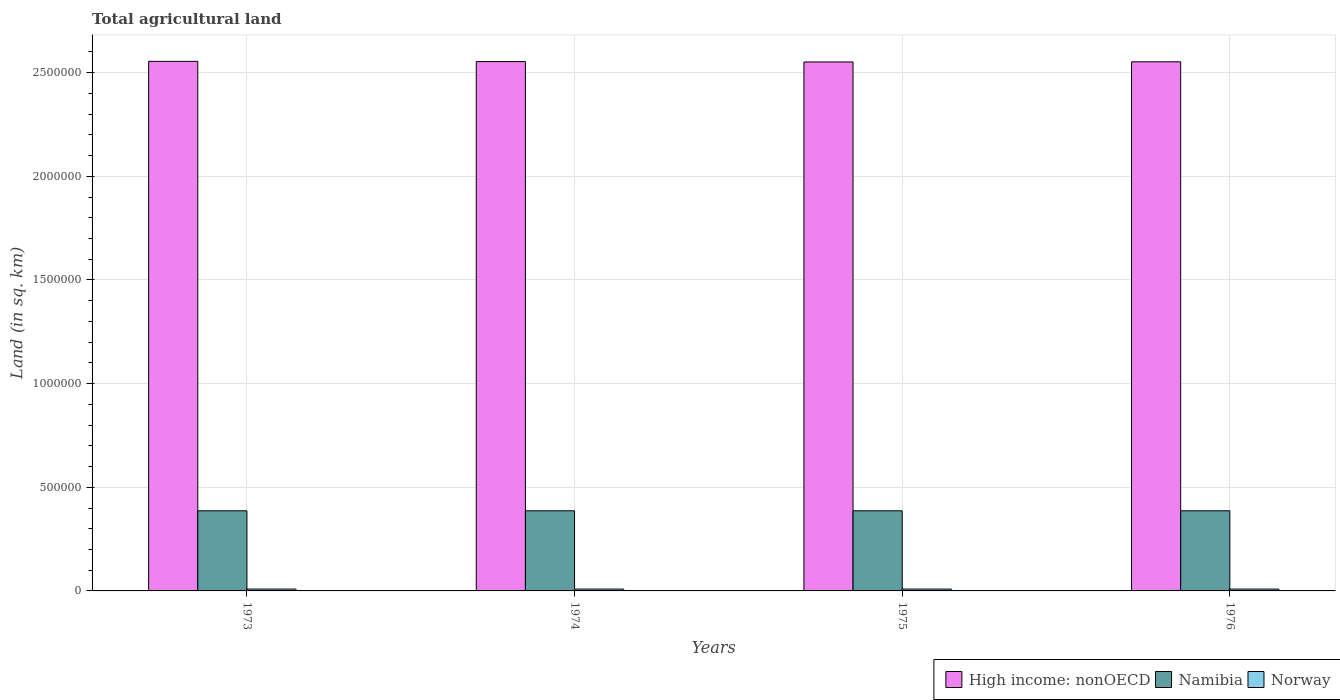Are the number of bars on each tick of the X-axis equal?
Provide a short and direct response. Yes. How many bars are there on the 2nd tick from the left?
Your answer should be compact. 3. What is the label of the 2nd group of bars from the left?
Your answer should be compact. 1974. In how many cases, is the number of bars for a given year not equal to the number of legend labels?
Your answer should be compact. 0. What is the total agricultural land in Namibia in 1974?
Give a very brief answer. 3.87e+05. Across all years, what is the maximum total agricultural land in High income: nonOECD?
Provide a succinct answer. 2.55e+06. Across all years, what is the minimum total agricultural land in High income: nonOECD?
Offer a very short reply. 2.55e+06. In which year was the total agricultural land in High income: nonOECD maximum?
Offer a very short reply. 1973. In which year was the total agricultural land in High income: nonOECD minimum?
Offer a very short reply. 1975. What is the total total agricultural land in High income: nonOECD in the graph?
Provide a short and direct response. 1.02e+07. What is the difference between the total agricultural land in Namibia in 1974 and that in 1976?
Keep it short and to the point. -20. What is the difference between the total agricultural land in Norway in 1976 and the total agricultural land in Namibia in 1974?
Provide a succinct answer. -3.78e+05. What is the average total agricultural land in Norway per year?
Ensure brevity in your answer.  8997.5. In the year 1975, what is the difference between the total agricultural land in Norway and total agricultural land in Namibia?
Your answer should be very brief. -3.78e+05. What is the ratio of the total agricultural land in High income: nonOECD in 1973 to that in 1975?
Provide a short and direct response. 1. Is the total agricultural land in Norway in 1974 less than that in 1976?
Provide a short and direct response. No. What is the difference between the highest and the lowest total agricultural land in Namibia?
Give a very brief answer. 20. In how many years, is the total agricultural land in High income: nonOECD greater than the average total agricultural land in High income: nonOECD taken over all years?
Make the answer very short. 2. What does the 2nd bar from the left in 1975 represents?
Ensure brevity in your answer.  Namibia. What does the 3rd bar from the right in 1976 represents?
Your answer should be compact. High income: nonOECD. Is it the case that in every year, the sum of the total agricultural land in Norway and total agricultural land in Namibia is greater than the total agricultural land in High income: nonOECD?
Your answer should be very brief. No. Are all the bars in the graph horizontal?
Provide a short and direct response. No. What is the difference between two consecutive major ticks on the Y-axis?
Offer a very short reply. 5.00e+05. Are the values on the major ticks of Y-axis written in scientific E-notation?
Your answer should be very brief. No. Does the graph contain grids?
Offer a very short reply. Yes. How are the legend labels stacked?
Keep it short and to the point. Horizontal. What is the title of the graph?
Your answer should be compact. Total agricultural land. Does "Vanuatu" appear as one of the legend labels in the graph?
Give a very brief answer. No. What is the label or title of the Y-axis?
Give a very brief answer. Land (in sq. km). What is the Land (in sq. km) in High income: nonOECD in 1973?
Offer a terse response. 2.55e+06. What is the Land (in sq. km) of Namibia in 1973?
Your answer should be compact. 3.87e+05. What is the Land (in sq. km) of Norway in 1973?
Your response must be concise. 9040. What is the Land (in sq. km) of High income: nonOECD in 1974?
Your answer should be compact. 2.55e+06. What is the Land (in sq. km) of Namibia in 1974?
Provide a succinct answer. 3.87e+05. What is the Land (in sq. km) of Norway in 1974?
Your answer should be compact. 9010. What is the Land (in sq. km) of High income: nonOECD in 1975?
Offer a terse response. 2.55e+06. What is the Land (in sq. km) of Namibia in 1975?
Your response must be concise. 3.87e+05. What is the Land (in sq. km) in Norway in 1975?
Keep it short and to the point. 8980. What is the Land (in sq. km) of High income: nonOECD in 1976?
Provide a succinct answer. 2.55e+06. What is the Land (in sq. km) in Namibia in 1976?
Ensure brevity in your answer.  3.87e+05. What is the Land (in sq. km) of Norway in 1976?
Ensure brevity in your answer.  8960. Across all years, what is the maximum Land (in sq. km) in High income: nonOECD?
Offer a terse response. 2.55e+06. Across all years, what is the maximum Land (in sq. km) in Namibia?
Provide a succinct answer. 3.87e+05. Across all years, what is the maximum Land (in sq. km) of Norway?
Offer a very short reply. 9040. Across all years, what is the minimum Land (in sq. km) of High income: nonOECD?
Offer a very short reply. 2.55e+06. Across all years, what is the minimum Land (in sq. km) of Namibia?
Your response must be concise. 3.87e+05. Across all years, what is the minimum Land (in sq. km) of Norway?
Make the answer very short. 8960. What is the total Land (in sq. km) in High income: nonOECD in the graph?
Provide a short and direct response. 1.02e+07. What is the total Land (in sq. km) in Namibia in the graph?
Make the answer very short. 1.55e+06. What is the total Land (in sq. km) of Norway in the graph?
Give a very brief answer. 3.60e+04. What is the difference between the Land (in sq. km) in High income: nonOECD in 1973 and that in 1974?
Give a very brief answer. 1118. What is the difference between the Land (in sq. km) of Namibia in 1973 and that in 1974?
Provide a short and direct response. 0. What is the difference between the Land (in sq. km) in High income: nonOECD in 1973 and that in 1975?
Your answer should be compact. 2931. What is the difference between the Land (in sq. km) of Namibia in 1973 and that in 1975?
Ensure brevity in your answer.  0. What is the difference between the Land (in sq. km) of High income: nonOECD in 1973 and that in 1976?
Offer a very short reply. 2169. What is the difference between the Land (in sq. km) of High income: nonOECD in 1974 and that in 1975?
Make the answer very short. 1813. What is the difference between the Land (in sq. km) of Namibia in 1974 and that in 1975?
Your answer should be very brief. 0. What is the difference between the Land (in sq. km) of Norway in 1974 and that in 1975?
Offer a terse response. 30. What is the difference between the Land (in sq. km) in High income: nonOECD in 1974 and that in 1976?
Provide a succinct answer. 1051. What is the difference between the Land (in sq. km) in High income: nonOECD in 1975 and that in 1976?
Offer a terse response. -762. What is the difference between the Land (in sq. km) in Namibia in 1975 and that in 1976?
Offer a terse response. -20. What is the difference between the Land (in sq. km) in Norway in 1975 and that in 1976?
Keep it short and to the point. 20. What is the difference between the Land (in sq. km) in High income: nonOECD in 1973 and the Land (in sq. km) in Namibia in 1974?
Provide a succinct answer. 2.17e+06. What is the difference between the Land (in sq. km) of High income: nonOECD in 1973 and the Land (in sq. km) of Norway in 1974?
Your answer should be very brief. 2.55e+06. What is the difference between the Land (in sq. km) of Namibia in 1973 and the Land (in sq. km) of Norway in 1974?
Your response must be concise. 3.78e+05. What is the difference between the Land (in sq. km) of High income: nonOECD in 1973 and the Land (in sq. km) of Namibia in 1975?
Provide a succinct answer. 2.17e+06. What is the difference between the Land (in sq. km) in High income: nonOECD in 1973 and the Land (in sq. km) in Norway in 1975?
Offer a terse response. 2.55e+06. What is the difference between the Land (in sq. km) of Namibia in 1973 and the Land (in sq. km) of Norway in 1975?
Provide a succinct answer. 3.78e+05. What is the difference between the Land (in sq. km) of High income: nonOECD in 1973 and the Land (in sq. km) of Namibia in 1976?
Your response must be concise. 2.17e+06. What is the difference between the Land (in sq. km) of High income: nonOECD in 1973 and the Land (in sq. km) of Norway in 1976?
Give a very brief answer. 2.55e+06. What is the difference between the Land (in sq. km) in Namibia in 1973 and the Land (in sq. km) in Norway in 1976?
Offer a terse response. 3.78e+05. What is the difference between the Land (in sq. km) in High income: nonOECD in 1974 and the Land (in sq. km) in Namibia in 1975?
Offer a very short reply. 2.17e+06. What is the difference between the Land (in sq. km) of High income: nonOECD in 1974 and the Land (in sq. km) of Norway in 1975?
Provide a short and direct response. 2.54e+06. What is the difference between the Land (in sq. km) in Namibia in 1974 and the Land (in sq. km) in Norway in 1975?
Provide a succinct answer. 3.78e+05. What is the difference between the Land (in sq. km) of High income: nonOECD in 1974 and the Land (in sq. km) of Namibia in 1976?
Keep it short and to the point. 2.17e+06. What is the difference between the Land (in sq. km) in High income: nonOECD in 1974 and the Land (in sq. km) in Norway in 1976?
Provide a succinct answer. 2.54e+06. What is the difference between the Land (in sq. km) in Namibia in 1974 and the Land (in sq. km) in Norway in 1976?
Give a very brief answer. 3.78e+05. What is the difference between the Land (in sq. km) of High income: nonOECD in 1975 and the Land (in sq. km) of Namibia in 1976?
Offer a terse response. 2.17e+06. What is the difference between the Land (in sq. km) in High income: nonOECD in 1975 and the Land (in sq. km) in Norway in 1976?
Make the answer very short. 2.54e+06. What is the difference between the Land (in sq. km) in Namibia in 1975 and the Land (in sq. km) in Norway in 1976?
Your answer should be very brief. 3.78e+05. What is the average Land (in sq. km) in High income: nonOECD per year?
Your answer should be compact. 2.55e+06. What is the average Land (in sq. km) in Namibia per year?
Keep it short and to the point. 3.87e+05. What is the average Land (in sq. km) in Norway per year?
Your response must be concise. 8997.5. In the year 1973, what is the difference between the Land (in sq. km) of High income: nonOECD and Land (in sq. km) of Namibia?
Ensure brevity in your answer.  2.17e+06. In the year 1973, what is the difference between the Land (in sq. km) of High income: nonOECD and Land (in sq. km) of Norway?
Your answer should be very brief. 2.55e+06. In the year 1973, what is the difference between the Land (in sq. km) in Namibia and Land (in sq. km) in Norway?
Your response must be concise. 3.77e+05. In the year 1974, what is the difference between the Land (in sq. km) of High income: nonOECD and Land (in sq. km) of Namibia?
Your response must be concise. 2.17e+06. In the year 1974, what is the difference between the Land (in sq. km) of High income: nonOECD and Land (in sq. km) of Norway?
Your answer should be compact. 2.54e+06. In the year 1974, what is the difference between the Land (in sq. km) of Namibia and Land (in sq. km) of Norway?
Ensure brevity in your answer.  3.78e+05. In the year 1975, what is the difference between the Land (in sq. km) of High income: nonOECD and Land (in sq. km) of Namibia?
Give a very brief answer. 2.17e+06. In the year 1975, what is the difference between the Land (in sq. km) of High income: nonOECD and Land (in sq. km) of Norway?
Provide a short and direct response. 2.54e+06. In the year 1975, what is the difference between the Land (in sq. km) of Namibia and Land (in sq. km) of Norway?
Your answer should be very brief. 3.78e+05. In the year 1976, what is the difference between the Land (in sq. km) in High income: nonOECD and Land (in sq. km) in Namibia?
Your answer should be very brief. 2.17e+06. In the year 1976, what is the difference between the Land (in sq. km) of High income: nonOECD and Land (in sq. km) of Norway?
Your response must be concise. 2.54e+06. In the year 1976, what is the difference between the Land (in sq. km) of Namibia and Land (in sq. km) of Norway?
Offer a very short reply. 3.78e+05. What is the ratio of the Land (in sq. km) of Namibia in 1973 to that in 1975?
Offer a terse response. 1. What is the ratio of the Land (in sq. km) in High income: nonOECD in 1973 to that in 1976?
Keep it short and to the point. 1. What is the ratio of the Land (in sq. km) of Namibia in 1973 to that in 1976?
Provide a succinct answer. 1. What is the ratio of the Land (in sq. km) in Norway in 1973 to that in 1976?
Your response must be concise. 1.01. What is the ratio of the Land (in sq. km) of Namibia in 1974 to that in 1975?
Keep it short and to the point. 1. What is the ratio of the Land (in sq. km) of Namibia in 1974 to that in 1976?
Ensure brevity in your answer.  1. What is the ratio of the Land (in sq. km) of Norway in 1974 to that in 1976?
Offer a very short reply. 1.01. What is the ratio of the Land (in sq. km) of High income: nonOECD in 1975 to that in 1976?
Keep it short and to the point. 1. What is the ratio of the Land (in sq. km) of Namibia in 1975 to that in 1976?
Your answer should be very brief. 1. What is the ratio of the Land (in sq. km) in Norway in 1975 to that in 1976?
Your response must be concise. 1. What is the difference between the highest and the second highest Land (in sq. km) in High income: nonOECD?
Offer a very short reply. 1118. What is the difference between the highest and the lowest Land (in sq. km) of High income: nonOECD?
Keep it short and to the point. 2931. What is the difference between the highest and the lowest Land (in sq. km) in Norway?
Your answer should be compact. 80. 